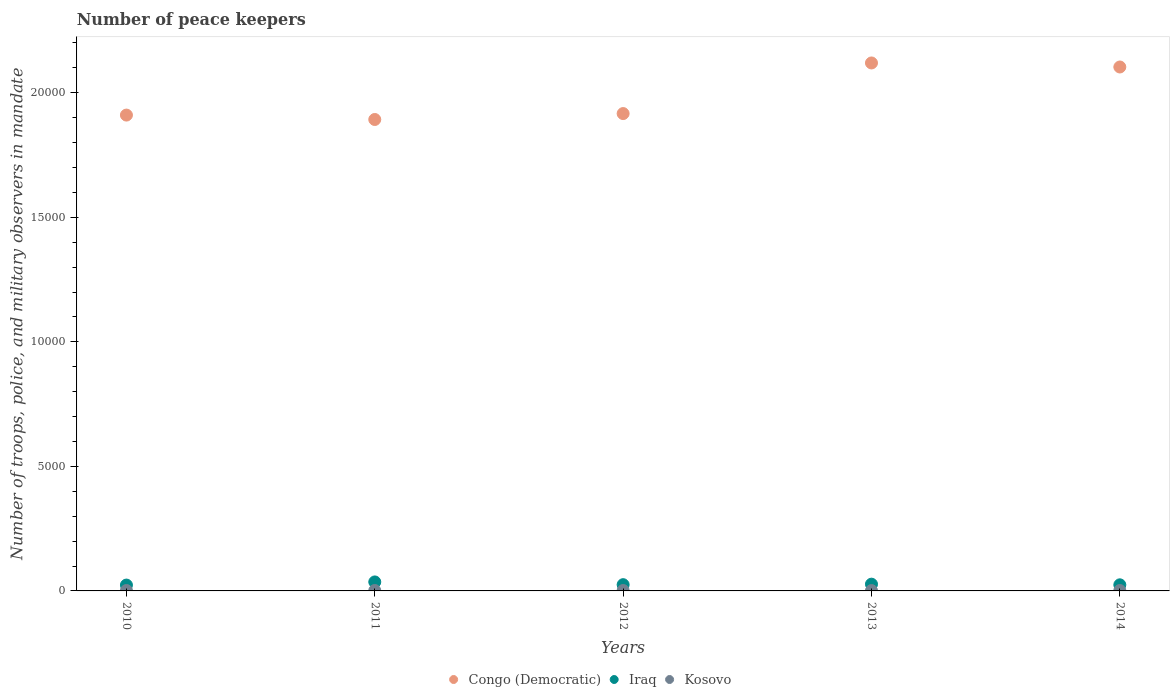How many different coloured dotlines are there?
Your answer should be very brief. 3. What is the number of peace keepers in in Kosovo in 2010?
Your answer should be compact. 16. Across all years, what is the minimum number of peace keepers in in Iraq?
Make the answer very short. 235. In which year was the number of peace keepers in in Kosovo maximum?
Ensure brevity in your answer.  2010. What is the total number of peace keepers in in Congo (Democratic) in the graph?
Ensure brevity in your answer.  9.94e+04. What is the difference between the number of peace keepers in in Congo (Democratic) in 2013 and that in 2014?
Your response must be concise. 162. What is the difference between the number of peace keepers in in Congo (Democratic) in 2011 and the number of peace keepers in in Iraq in 2012?
Give a very brief answer. 1.87e+04. What is the average number of peace keepers in in Congo (Democratic) per year?
Your answer should be compact. 1.99e+04. In the year 2013, what is the difference between the number of peace keepers in in Iraq and number of peace keepers in in Kosovo?
Provide a short and direct response. 257. In how many years, is the number of peace keepers in in Iraq greater than 12000?
Your answer should be compact. 0. What is the ratio of the number of peace keepers in in Iraq in 2010 to that in 2014?
Provide a succinct answer. 0.96. Is the number of peace keepers in in Iraq in 2010 less than that in 2013?
Your response must be concise. Yes. What is the difference between the highest and the second highest number of peace keepers in in Congo (Democratic)?
Your answer should be compact. 162. What is the difference between the highest and the lowest number of peace keepers in in Congo (Democratic)?
Give a very brief answer. 2270. In how many years, is the number of peace keepers in in Congo (Democratic) greater than the average number of peace keepers in in Congo (Democratic) taken over all years?
Give a very brief answer. 2. Is it the case that in every year, the sum of the number of peace keepers in in Kosovo and number of peace keepers in in Iraq  is greater than the number of peace keepers in in Congo (Democratic)?
Ensure brevity in your answer.  No. Is the number of peace keepers in in Congo (Democratic) strictly greater than the number of peace keepers in in Iraq over the years?
Give a very brief answer. Yes. How many dotlines are there?
Offer a very short reply. 3. Are the values on the major ticks of Y-axis written in scientific E-notation?
Your answer should be compact. No. Does the graph contain any zero values?
Provide a succinct answer. No. How many legend labels are there?
Provide a short and direct response. 3. What is the title of the graph?
Make the answer very short. Number of peace keepers. What is the label or title of the X-axis?
Your answer should be compact. Years. What is the label or title of the Y-axis?
Offer a very short reply. Number of troops, police, and military observers in mandate. What is the Number of troops, police, and military observers in mandate in Congo (Democratic) in 2010?
Offer a very short reply. 1.91e+04. What is the Number of troops, police, and military observers in mandate in Iraq in 2010?
Ensure brevity in your answer.  235. What is the Number of troops, police, and military observers in mandate of Kosovo in 2010?
Give a very brief answer. 16. What is the Number of troops, police, and military observers in mandate in Congo (Democratic) in 2011?
Provide a short and direct response. 1.89e+04. What is the Number of troops, police, and military observers in mandate of Iraq in 2011?
Provide a succinct answer. 361. What is the Number of troops, police, and military observers in mandate of Congo (Democratic) in 2012?
Give a very brief answer. 1.92e+04. What is the Number of troops, police, and military observers in mandate of Iraq in 2012?
Offer a very short reply. 251. What is the Number of troops, police, and military observers in mandate of Congo (Democratic) in 2013?
Give a very brief answer. 2.12e+04. What is the Number of troops, police, and military observers in mandate in Iraq in 2013?
Make the answer very short. 271. What is the Number of troops, police, and military observers in mandate in Kosovo in 2013?
Offer a terse response. 14. What is the Number of troops, police, and military observers in mandate of Congo (Democratic) in 2014?
Your answer should be very brief. 2.10e+04. What is the Number of troops, police, and military observers in mandate of Iraq in 2014?
Keep it short and to the point. 245. What is the Number of troops, police, and military observers in mandate in Kosovo in 2014?
Your response must be concise. 16. Across all years, what is the maximum Number of troops, police, and military observers in mandate of Congo (Democratic)?
Your response must be concise. 2.12e+04. Across all years, what is the maximum Number of troops, police, and military observers in mandate in Iraq?
Offer a terse response. 361. Across all years, what is the maximum Number of troops, police, and military observers in mandate in Kosovo?
Keep it short and to the point. 16. Across all years, what is the minimum Number of troops, police, and military observers in mandate of Congo (Democratic)?
Offer a terse response. 1.89e+04. Across all years, what is the minimum Number of troops, police, and military observers in mandate in Iraq?
Your answer should be compact. 235. What is the total Number of troops, police, and military observers in mandate of Congo (Democratic) in the graph?
Keep it short and to the point. 9.94e+04. What is the total Number of troops, police, and military observers in mandate in Iraq in the graph?
Offer a terse response. 1363. What is the total Number of troops, police, and military observers in mandate in Kosovo in the graph?
Provide a succinct answer. 78. What is the difference between the Number of troops, police, and military observers in mandate of Congo (Democratic) in 2010 and that in 2011?
Your response must be concise. 177. What is the difference between the Number of troops, police, and military observers in mandate of Iraq in 2010 and that in 2011?
Make the answer very short. -126. What is the difference between the Number of troops, police, and military observers in mandate in Kosovo in 2010 and that in 2011?
Your response must be concise. 0. What is the difference between the Number of troops, police, and military observers in mandate of Congo (Democratic) in 2010 and that in 2012?
Offer a terse response. -61. What is the difference between the Number of troops, police, and military observers in mandate in Kosovo in 2010 and that in 2012?
Give a very brief answer. 0. What is the difference between the Number of troops, police, and military observers in mandate of Congo (Democratic) in 2010 and that in 2013?
Give a very brief answer. -2093. What is the difference between the Number of troops, police, and military observers in mandate of Iraq in 2010 and that in 2013?
Ensure brevity in your answer.  -36. What is the difference between the Number of troops, police, and military observers in mandate in Kosovo in 2010 and that in 2013?
Make the answer very short. 2. What is the difference between the Number of troops, police, and military observers in mandate of Congo (Democratic) in 2010 and that in 2014?
Your response must be concise. -1931. What is the difference between the Number of troops, police, and military observers in mandate of Kosovo in 2010 and that in 2014?
Your response must be concise. 0. What is the difference between the Number of troops, police, and military observers in mandate of Congo (Democratic) in 2011 and that in 2012?
Keep it short and to the point. -238. What is the difference between the Number of troops, police, and military observers in mandate of Iraq in 2011 and that in 2012?
Ensure brevity in your answer.  110. What is the difference between the Number of troops, police, and military observers in mandate in Congo (Democratic) in 2011 and that in 2013?
Keep it short and to the point. -2270. What is the difference between the Number of troops, police, and military observers in mandate of Congo (Democratic) in 2011 and that in 2014?
Ensure brevity in your answer.  -2108. What is the difference between the Number of troops, police, and military observers in mandate of Iraq in 2011 and that in 2014?
Give a very brief answer. 116. What is the difference between the Number of troops, police, and military observers in mandate of Congo (Democratic) in 2012 and that in 2013?
Provide a short and direct response. -2032. What is the difference between the Number of troops, police, and military observers in mandate of Iraq in 2012 and that in 2013?
Offer a very short reply. -20. What is the difference between the Number of troops, police, and military observers in mandate in Kosovo in 2012 and that in 2013?
Your response must be concise. 2. What is the difference between the Number of troops, police, and military observers in mandate of Congo (Democratic) in 2012 and that in 2014?
Your answer should be compact. -1870. What is the difference between the Number of troops, police, and military observers in mandate in Kosovo in 2012 and that in 2014?
Provide a short and direct response. 0. What is the difference between the Number of troops, police, and military observers in mandate in Congo (Democratic) in 2013 and that in 2014?
Offer a terse response. 162. What is the difference between the Number of troops, police, and military observers in mandate of Iraq in 2013 and that in 2014?
Keep it short and to the point. 26. What is the difference between the Number of troops, police, and military observers in mandate in Kosovo in 2013 and that in 2014?
Provide a succinct answer. -2. What is the difference between the Number of troops, police, and military observers in mandate in Congo (Democratic) in 2010 and the Number of troops, police, and military observers in mandate in Iraq in 2011?
Offer a terse response. 1.87e+04. What is the difference between the Number of troops, police, and military observers in mandate in Congo (Democratic) in 2010 and the Number of troops, police, and military observers in mandate in Kosovo in 2011?
Offer a very short reply. 1.91e+04. What is the difference between the Number of troops, police, and military observers in mandate of Iraq in 2010 and the Number of troops, police, and military observers in mandate of Kosovo in 2011?
Provide a succinct answer. 219. What is the difference between the Number of troops, police, and military observers in mandate of Congo (Democratic) in 2010 and the Number of troops, police, and military observers in mandate of Iraq in 2012?
Offer a terse response. 1.89e+04. What is the difference between the Number of troops, police, and military observers in mandate of Congo (Democratic) in 2010 and the Number of troops, police, and military observers in mandate of Kosovo in 2012?
Offer a very short reply. 1.91e+04. What is the difference between the Number of troops, police, and military observers in mandate in Iraq in 2010 and the Number of troops, police, and military observers in mandate in Kosovo in 2012?
Give a very brief answer. 219. What is the difference between the Number of troops, police, and military observers in mandate of Congo (Democratic) in 2010 and the Number of troops, police, and military observers in mandate of Iraq in 2013?
Offer a terse response. 1.88e+04. What is the difference between the Number of troops, police, and military observers in mandate of Congo (Democratic) in 2010 and the Number of troops, police, and military observers in mandate of Kosovo in 2013?
Make the answer very short. 1.91e+04. What is the difference between the Number of troops, police, and military observers in mandate in Iraq in 2010 and the Number of troops, police, and military observers in mandate in Kosovo in 2013?
Make the answer very short. 221. What is the difference between the Number of troops, police, and military observers in mandate of Congo (Democratic) in 2010 and the Number of troops, police, and military observers in mandate of Iraq in 2014?
Your response must be concise. 1.89e+04. What is the difference between the Number of troops, police, and military observers in mandate of Congo (Democratic) in 2010 and the Number of troops, police, and military observers in mandate of Kosovo in 2014?
Give a very brief answer. 1.91e+04. What is the difference between the Number of troops, police, and military observers in mandate in Iraq in 2010 and the Number of troops, police, and military observers in mandate in Kosovo in 2014?
Your answer should be very brief. 219. What is the difference between the Number of troops, police, and military observers in mandate in Congo (Democratic) in 2011 and the Number of troops, police, and military observers in mandate in Iraq in 2012?
Provide a short and direct response. 1.87e+04. What is the difference between the Number of troops, police, and military observers in mandate of Congo (Democratic) in 2011 and the Number of troops, police, and military observers in mandate of Kosovo in 2012?
Keep it short and to the point. 1.89e+04. What is the difference between the Number of troops, police, and military observers in mandate of Iraq in 2011 and the Number of troops, police, and military observers in mandate of Kosovo in 2012?
Ensure brevity in your answer.  345. What is the difference between the Number of troops, police, and military observers in mandate of Congo (Democratic) in 2011 and the Number of troops, police, and military observers in mandate of Iraq in 2013?
Make the answer very short. 1.87e+04. What is the difference between the Number of troops, police, and military observers in mandate of Congo (Democratic) in 2011 and the Number of troops, police, and military observers in mandate of Kosovo in 2013?
Your response must be concise. 1.89e+04. What is the difference between the Number of troops, police, and military observers in mandate of Iraq in 2011 and the Number of troops, police, and military observers in mandate of Kosovo in 2013?
Give a very brief answer. 347. What is the difference between the Number of troops, police, and military observers in mandate of Congo (Democratic) in 2011 and the Number of troops, police, and military observers in mandate of Iraq in 2014?
Provide a short and direct response. 1.87e+04. What is the difference between the Number of troops, police, and military observers in mandate in Congo (Democratic) in 2011 and the Number of troops, police, and military observers in mandate in Kosovo in 2014?
Ensure brevity in your answer.  1.89e+04. What is the difference between the Number of troops, police, and military observers in mandate in Iraq in 2011 and the Number of troops, police, and military observers in mandate in Kosovo in 2014?
Make the answer very short. 345. What is the difference between the Number of troops, police, and military observers in mandate in Congo (Democratic) in 2012 and the Number of troops, police, and military observers in mandate in Iraq in 2013?
Give a very brief answer. 1.89e+04. What is the difference between the Number of troops, police, and military observers in mandate in Congo (Democratic) in 2012 and the Number of troops, police, and military observers in mandate in Kosovo in 2013?
Your answer should be compact. 1.92e+04. What is the difference between the Number of troops, police, and military observers in mandate in Iraq in 2012 and the Number of troops, police, and military observers in mandate in Kosovo in 2013?
Offer a very short reply. 237. What is the difference between the Number of troops, police, and military observers in mandate of Congo (Democratic) in 2012 and the Number of troops, police, and military observers in mandate of Iraq in 2014?
Ensure brevity in your answer.  1.89e+04. What is the difference between the Number of troops, police, and military observers in mandate in Congo (Democratic) in 2012 and the Number of troops, police, and military observers in mandate in Kosovo in 2014?
Offer a terse response. 1.92e+04. What is the difference between the Number of troops, police, and military observers in mandate in Iraq in 2012 and the Number of troops, police, and military observers in mandate in Kosovo in 2014?
Your answer should be very brief. 235. What is the difference between the Number of troops, police, and military observers in mandate in Congo (Democratic) in 2013 and the Number of troops, police, and military observers in mandate in Iraq in 2014?
Ensure brevity in your answer.  2.10e+04. What is the difference between the Number of troops, police, and military observers in mandate in Congo (Democratic) in 2013 and the Number of troops, police, and military observers in mandate in Kosovo in 2014?
Provide a short and direct response. 2.12e+04. What is the difference between the Number of troops, police, and military observers in mandate in Iraq in 2013 and the Number of troops, police, and military observers in mandate in Kosovo in 2014?
Provide a short and direct response. 255. What is the average Number of troops, police, and military observers in mandate of Congo (Democratic) per year?
Your answer should be very brief. 1.99e+04. What is the average Number of troops, police, and military observers in mandate in Iraq per year?
Make the answer very short. 272.6. What is the average Number of troops, police, and military observers in mandate in Kosovo per year?
Ensure brevity in your answer.  15.6. In the year 2010, what is the difference between the Number of troops, police, and military observers in mandate of Congo (Democratic) and Number of troops, police, and military observers in mandate of Iraq?
Your answer should be very brief. 1.89e+04. In the year 2010, what is the difference between the Number of troops, police, and military observers in mandate of Congo (Democratic) and Number of troops, police, and military observers in mandate of Kosovo?
Make the answer very short. 1.91e+04. In the year 2010, what is the difference between the Number of troops, police, and military observers in mandate in Iraq and Number of troops, police, and military observers in mandate in Kosovo?
Provide a succinct answer. 219. In the year 2011, what is the difference between the Number of troops, police, and military observers in mandate of Congo (Democratic) and Number of troops, police, and military observers in mandate of Iraq?
Keep it short and to the point. 1.86e+04. In the year 2011, what is the difference between the Number of troops, police, and military observers in mandate in Congo (Democratic) and Number of troops, police, and military observers in mandate in Kosovo?
Provide a short and direct response. 1.89e+04. In the year 2011, what is the difference between the Number of troops, police, and military observers in mandate in Iraq and Number of troops, police, and military observers in mandate in Kosovo?
Your answer should be compact. 345. In the year 2012, what is the difference between the Number of troops, police, and military observers in mandate of Congo (Democratic) and Number of troops, police, and military observers in mandate of Iraq?
Make the answer very short. 1.89e+04. In the year 2012, what is the difference between the Number of troops, police, and military observers in mandate in Congo (Democratic) and Number of troops, police, and military observers in mandate in Kosovo?
Offer a very short reply. 1.92e+04. In the year 2012, what is the difference between the Number of troops, police, and military observers in mandate of Iraq and Number of troops, police, and military observers in mandate of Kosovo?
Ensure brevity in your answer.  235. In the year 2013, what is the difference between the Number of troops, police, and military observers in mandate in Congo (Democratic) and Number of troops, police, and military observers in mandate in Iraq?
Keep it short and to the point. 2.09e+04. In the year 2013, what is the difference between the Number of troops, police, and military observers in mandate of Congo (Democratic) and Number of troops, police, and military observers in mandate of Kosovo?
Provide a succinct answer. 2.12e+04. In the year 2013, what is the difference between the Number of troops, police, and military observers in mandate in Iraq and Number of troops, police, and military observers in mandate in Kosovo?
Ensure brevity in your answer.  257. In the year 2014, what is the difference between the Number of troops, police, and military observers in mandate of Congo (Democratic) and Number of troops, police, and military observers in mandate of Iraq?
Provide a succinct answer. 2.08e+04. In the year 2014, what is the difference between the Number of troops, police, and military observers in mandate in Congo (Democratic) and Number of troops, police, and military observers in mandate in Kosovo?
Provide a succinct answer. 2.10e+04. In the year 2014, what is the difference between the Number of troops, police, and military observers in mandate in Iraq and Number of troops, police, and military observers in mandate in Kosovo?
Your answer should be very brief. 229. What is the ratio of the Number of troops, police, and military observers in mandate in Congo (Democratic) in 2010 to that in 2011?
Offer a terse response. 1.01. What is the ratio of the Number of troops, police, and military observers in mandate in Iraq in 2010 to that in 2011?
Offer a very short reply. 0.65. What is the ratio of the Number of troops, police, and military observers in mandate of Iraq in 2010 to that in 2012?
Give a very brief answer. 0.94. What is the ratio of the Number of troops, police, and military observers in mandate of Kosovo in 2010 to that in 2012?
Make the answer very short. 1. What is the ratio of the Number of troops, police, and military observers in mandate in Congo (Democratic) in 2010 to that in 2013?
Provide a succinct answer. 0.9. What is the ratio of the Number of troops, police, and military observers in mandate in Iraq in 2010 to that in 2013?
Your answer should be very brief. 0.87. What is the ratio of the Number of troops, police, and military observers in mandate of Kosovo in 2010 to that in 2013?
Offer a terse response. 1.14. What is the ratio of the Number of troops, police, and military observers in mandate in Congo (Democratic) in 2010 to that in 2014?
Your answer should be very brief. 0.91. What is the ratio of the Number of troops, police, and military observers in mandate of Iraq in 2010 to that in 2014?
Your response must be concise. 0.96. What is the ratio of the Number of troops, police, and military observers in mandate of Congo (Democratic) in 2011 to that in 2012?
Keep it short and to the point. 0.99. What is the ratio of the Number of troops, police, and military observers in mandate in Iraq in 2011 to that in 2012?
Keep it short and to the point. 1.44. What is the ratio of the Number of troops, police, and military observers in mandate in Congo (Democratic) in 2011 to that in 2013?
Make the answer very short. 0.89. What is the ratio of the Number of troops, police, and military observers in mandate in Iraq in 2011 to that in 2013?
Offer a terse response. 1.33. What is the ratio of the Number of troops, police, and military observers in mandate of Congo (Democratic) in 2011 to that in 2014?
Offer a terse response. 0.9. What is the ratio of the Number of troops, police, and military observers in mandate in Iraq in 2011 to that in 2014?
Your response must be concise. 1.47. What is the ratio of the Number of troops, police, and military observers in mandate of Kosovo in 2011 to that in 2014?
Your answer should be very brief. 1. What is the ratio of the Number of troops, police, and military observers in mandate of Congo (Democratic) in 2012 to that in 2013?
Offer a very short reply. 0.9. What is the ratio of the Number of troops, police, and military observers in mandate of Iraq in 2012 to that in 2013?
Give a very brief answer. 0.93. What is the ratio of the Number of troops, police, and military observers in mandate in Congo (Democratic) in 2012 to that in 2014?
Your answer should be very brief. 0.91. What is the ratio of the Number of troops, police, and military observers in mandate of Iraq in 2012 to that in 2014?
Keep it short and to the point. 1.02. What is the ratio of the Number of troops, police, and military observers in mandate in Kosovo in 2012 to that in 2014?
Your answer should be compact. 1. What is the ratio of the Number of troops, police, and military observers in mandate of Congo (Democratic) in 2013 to that in 2014?
Give a very brief answer. 1.01. What is the ratio of the Number of troops, police, and military observers in mandate in Iraq in 2013 to that in 2014?
Your response must be concise. 1.11. What is the difference between the highest and the second highest Number of troops, police, and military observers in mandate in Congo (Democratic)?
Provide a succinct answer. 162. What is the difference between the highest and the second highest Number of troops, police, and military observers in mandate in Iraq?
Provide a short and direct response. 90. What is the difference between the highest and the lowest Number of troops, police, and military observers in mandate in Congo (Democratic)?
Make the answer very short. 2270. What is the difference between the highest and the lowest Number of troops, police, and military observers in mandate in Iraq?
Give a very brief answer. 126. What is the difference between the highest and the lowest Number of troops, police, and military observers in mandate of Kosovo?
Provide a short and direct response. 2. 